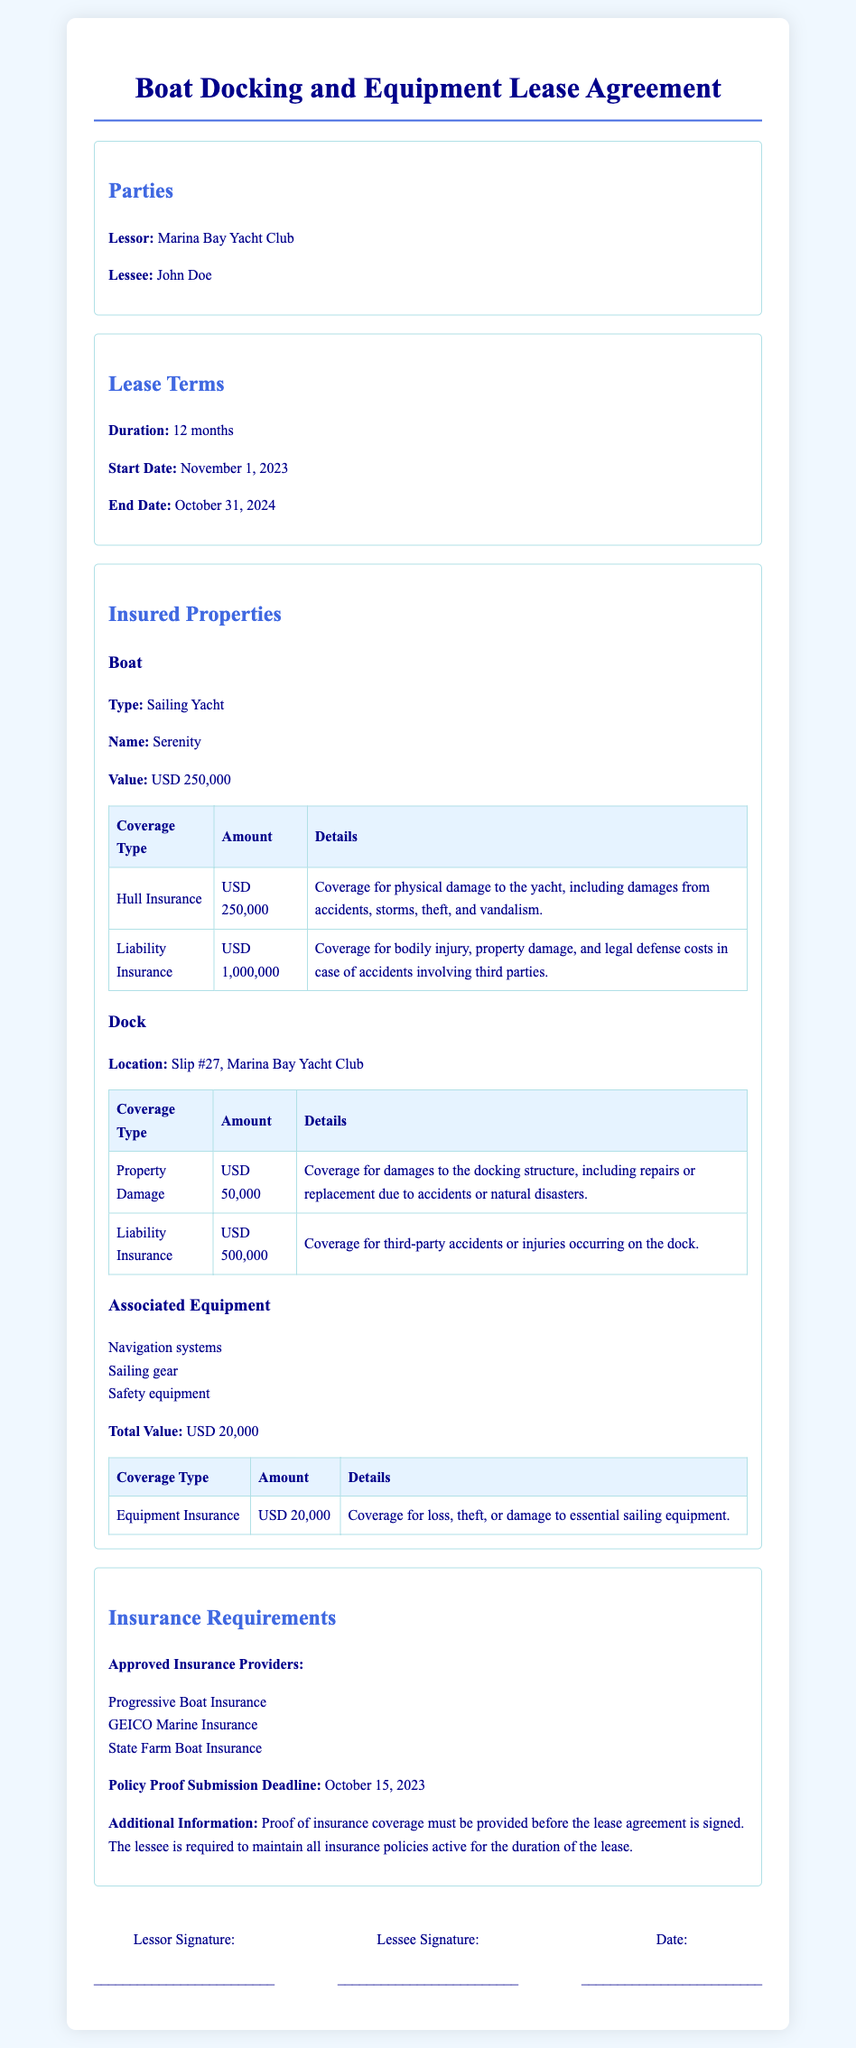what is the duration of the lease? The lease duration is explicitly stated in the lease terms section.
Answer: 12 months what is the value of the boat? The value of the boat is mentioned under the insured properties section.
Answer: USD 250,000 how much is the liability insurance for the boat? The amount for liability insurance is specified in the coverage table for the boat.
Answer: USD 1,000,000 where is the dock located? The location of the dock is provided in the insured properties section.
Answer: Slip #27, Marina Bay Yacht Club who are the approved insurance providers? A list of approved insurance providers is given in the insurance requirements section.
Answer: Progressive Boat Insurance, GEICO Marine Insurance, State Farm Boat Insurance what is the total value of associated equipment? The total value of associated equipment is stated in the respective section.
Answer: USD 20,000 when is the policy proof submission deadline? The submission deadline for the policy proof is mentioned in the insurance requirements section.
Answer: October 15, 2023 what type of boat is covered under this lease agreement? The type of boat is specified in the insured properties section.
Answer: Sailing Yacht how much is the property damage coverage for the dock? The specific amount for property damage coverage is found in the coverage table for the dock.
Answer: USD 50,000 